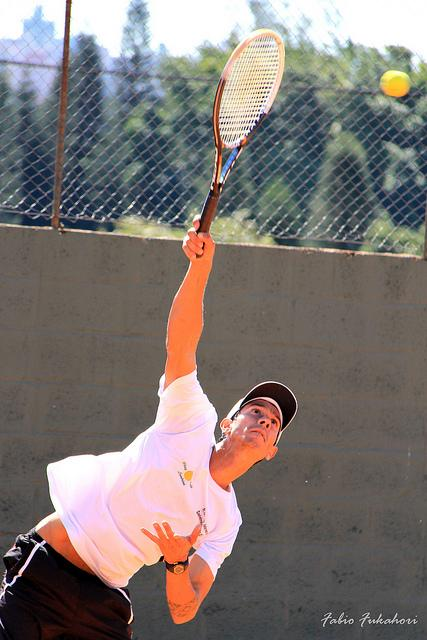What is his wrist accessory used for? time 